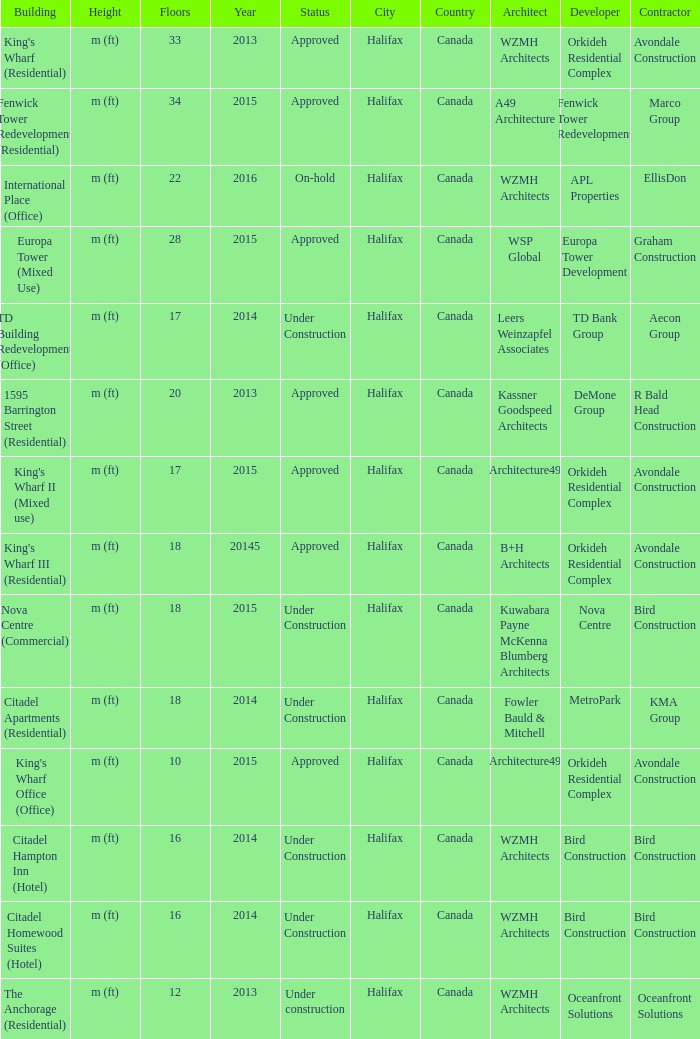What building shows 2013 and has more than 20 floors? King's Wharf (Residential). 